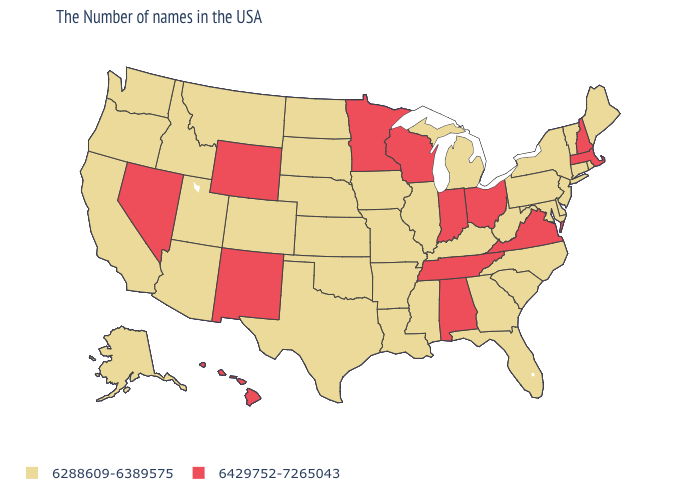Name the states that have a value in the range 6429752-7265043?
Be succinct. Massachusetts, New Hampshire, Virginia, Ohio, Indiana, Alabama, Tennessee, Wisconsin, Minnesota, Wyoming, New Mexico, Nevada, Hawaii. Which states hav the highest value in the West?
Answer briefly. Wyoming, New Mexico, Nevada, Hawaii. What is the value of Connecticut?
Quick response, please. 6288609-6389575. What is the value of West Virginia?
Give a very brief answer. 6288609-6389575. What is the value of Maine?
Write a very short answer. 6288609-6389575. Name the states that have a value in the range 6429752-7265043?
Quick response, please. Massachusetts, New Hampshire, Virginia, Ohio, Indiana, Alabama, Tennessee, Wisconsin, Minnesota, Wyoming, New Mexico, Nevada, Hawaii. Name the states that have a value in the range 6429752-7265043?
Give a very brief answer. Massachusetts, New Hampshire, Virginia, Ohio, Indiana, Alabama, Tennessee, Wisconsin, Minnesota, Wyoming, New Mexico, Nevada, Hawaii. What is the value of South Dakota?
Write a very short answer. 6288609-6389575. What is the lowest value in states that border Nebraska?
Keep it brief. 6288609-6389575. Name the states that have a value in the range 6288609-6389575?
Short answer required. Maine, Rhode Island, Vermont, Connecticut, New York, New Jersey, Delaware, Maryland, Pennsylvania, North Carolina, South Carolina, West Virginia, Florida, Georgia, Michigan, Kentucky, Illinois, Mississippi, Louisiana, Missouri, Arkansas, Iowa, Kansas, Nebraska, Oklahoma, Texas, South Dakota, North Dakota, Colorado, Utah, Montana, Arizona, Idaho, California, Washington, Oregon, Alaska. What is the value of North Carolina?
Give a very brief answer. 6288609-6389575. Which states have the highest value in the USA?
Short answer required. Massachusetts, New Hampshire, Virginia, Ohio, Indiana, Alabama, Tennessee, Wisconsin, Minnesota, Wyoming, New Mexico, Nevada, Hawaii. Which states have the highest value in the USA?
Keep it brief. Massachusetts, New Hampshire, Virginia, Ohio, Indiana, Alabama, Tennessee, Wisconsin, Minnesota, Wyoming, New Mexico, Nevada, Hawaii. What is the value of Nevada?
Write a very short answer. 6429752-7265043. 